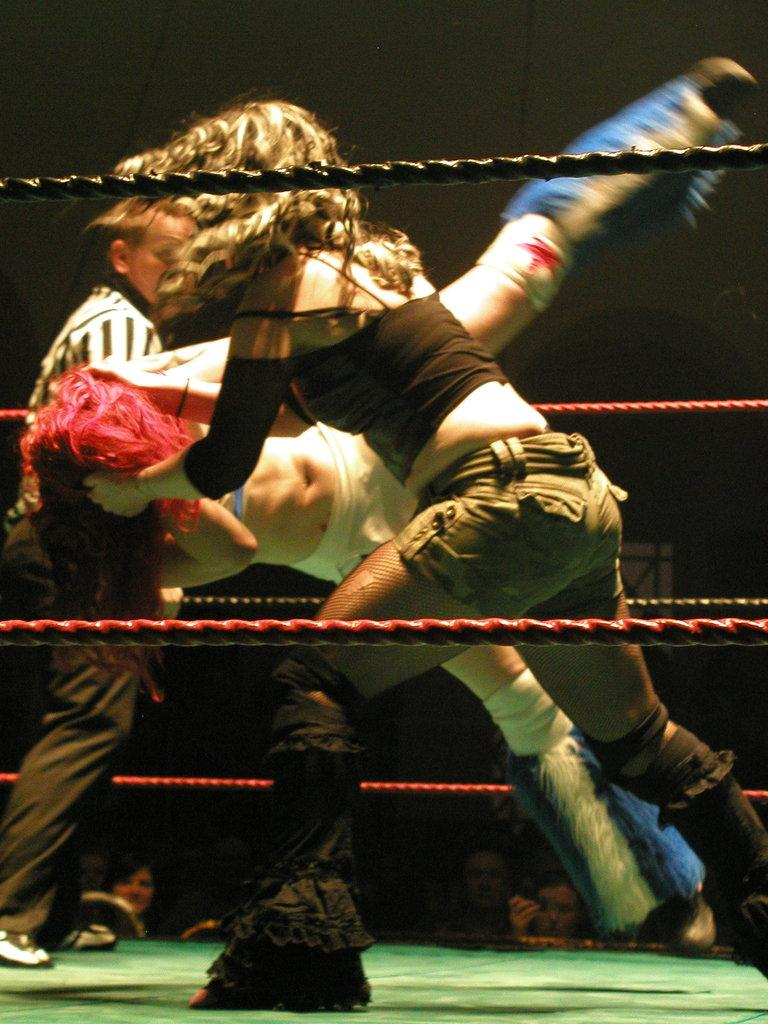How many people are present in the image? There are 3 persons in the image. Can you describe the gender of the people in the image? Yes, there is a woman and a man in the image. What is one person doing to another person's head in the image? One person is holding another person's head in the image. How many geese are present in the image? There are no geese present in the image. What type of health advice can be seen being given in the image? There is no health advice present in the image. How many kittens can be seen playing with the people in the image? There are no kittens present in the image. 